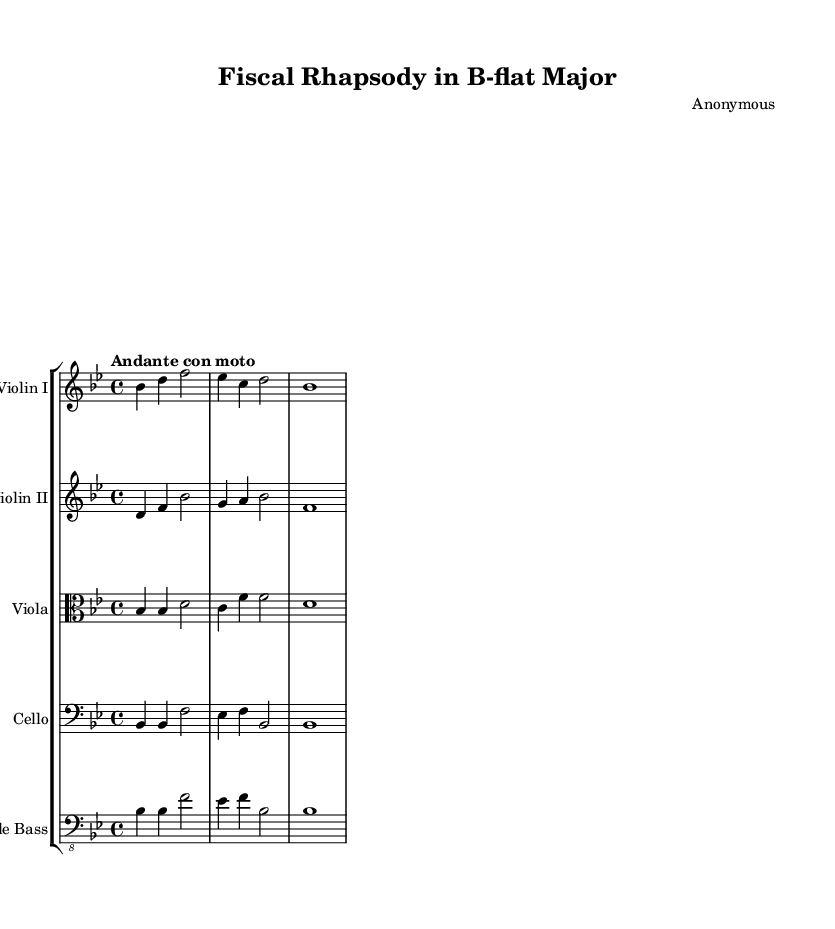What is the key signature of this music? The key signature has two flats, indicating the piece is in B-flat major. The symbol for B-flat and E-flat appears at the beginning of the staff.
Answer: B-flat major What is the time signature of the piece? The time signature is indicated as 4/4, meaning there are four beats in each measure and the quarter note gets one beat. This is seen at the beginning of the sheet music.
Answer: 4/4 What is the tempo marking of the piece? The tempo marking indicates "Andante con moto," which is a moderate tempo with some movement. This phrase is included just above the staff at the start of the music.
Answer: Andante con moto How many measures are there in the entire score? Counting all the measures across the different instruments, there are a total of 8 measures in the score provided. This includes the measures from each individual part.
Answer: 8 Which instruments are featured in this orchestral work? The orchestral work features a group of strings, specifically Violin I, Violin II, Viola, Cello, and Double Bass, which can be observed in the staff listings at the beginning of the score.
Answer: Violin I, Violin II, Viola, Cello, Double Bass What is the highest pitch in the Violin I part? The Violin I part reaches the note D, which is the highest pitch in that staff section. This visual information is derived from the specific pitches notated in the Violin I line.
Answer: D What thematic element does this piece possibly represent related to finance? The title "Fiscal Rhapsody" suggests that the piece explores themes of finance and economics, indicative of cycles of wealth and decline, typical of the Romantic period's exploration of broader societal themes.
Answer: Financial Themes 